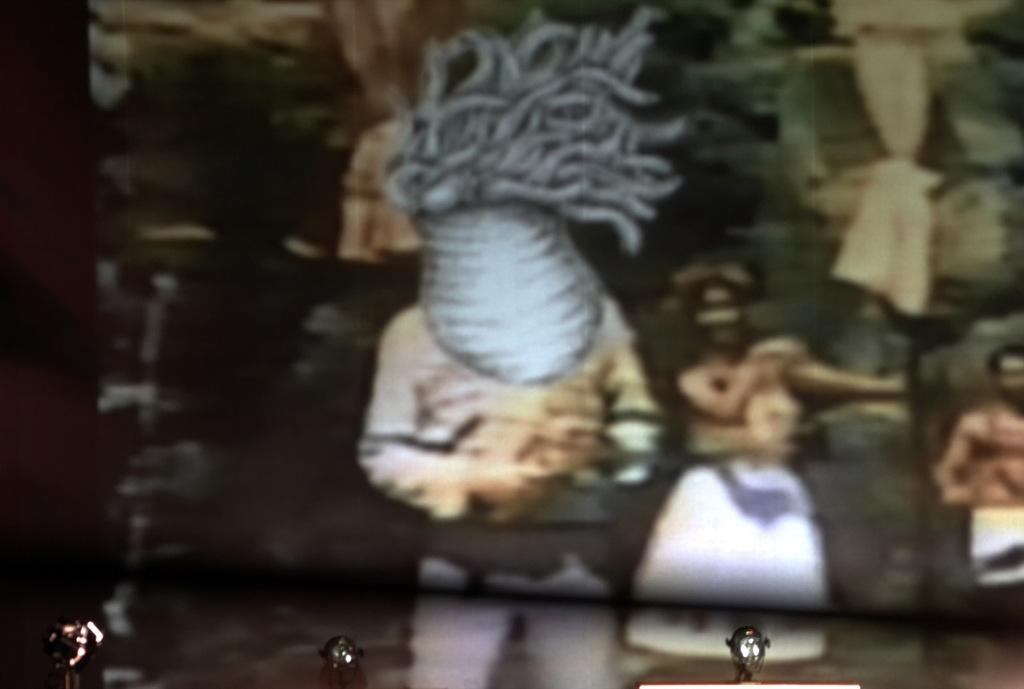What is the main subject of the image? The main subject of the image is an old photo. Are there any other objects visible in the image besides the old photo? Yes, there are other objects in the image. How many hands are visible in the image? There is no mention of hands in the provided facts, so we cannot determine if any are visible in the image. 